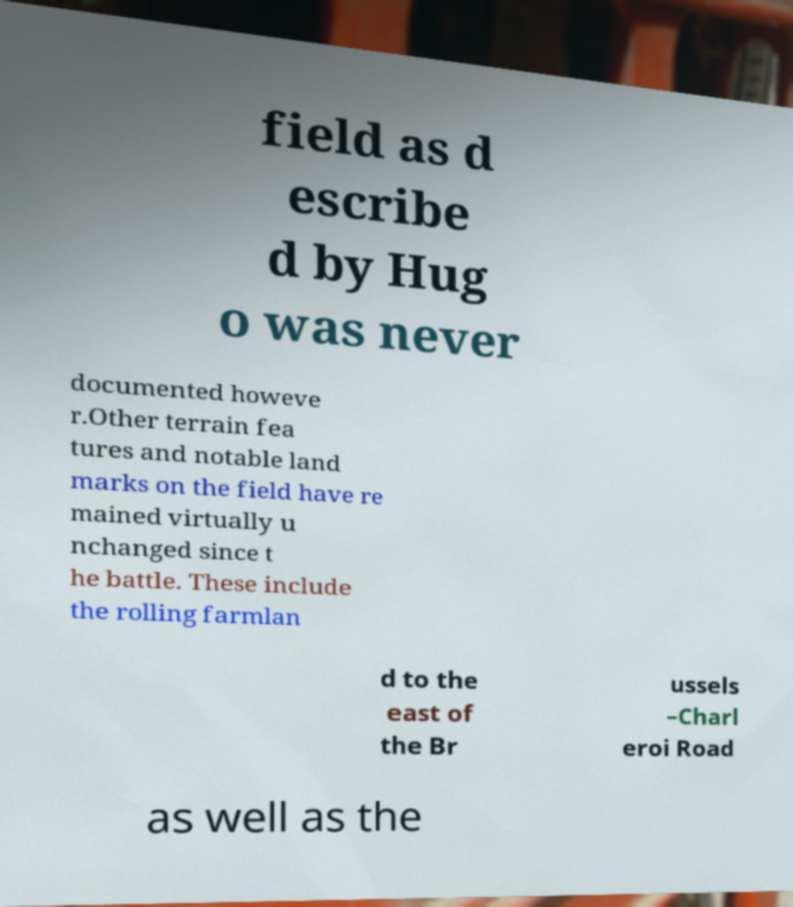What messages or text are displayed in this image? I need them in a readable, typed format. field as d escribe d by Hug o was never documented howeve r.Other terrain fea tures and notable land marks on the field have re mained virtually u nchanged since t he battle. These include the rolling farmlan d to the east of the Br ussels –Charl eroi Road as well as the 